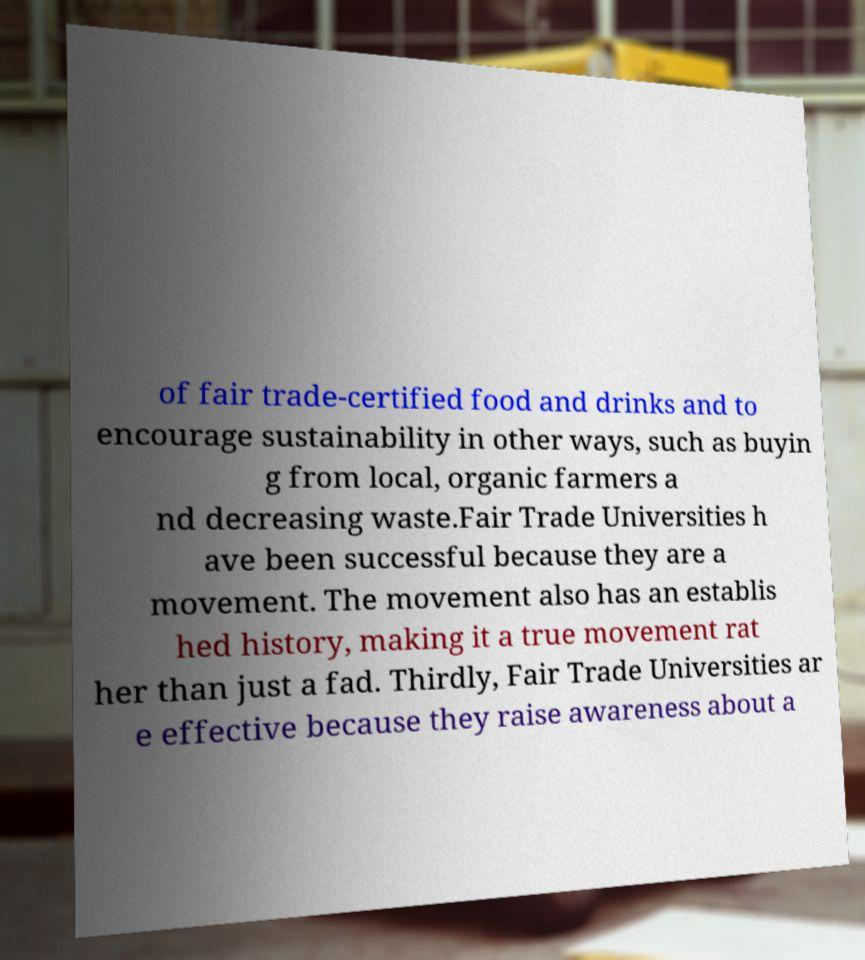Could you extract and type out the text from this image? of fair trade-certified food and drinks and to encourage sustainability in other ways, such as buyin g from local, organic farmers a nd decreasing waste.Fair Trade Universities h ave been successful because they are a movement. The movement also has an establis hed history, making it a true movement rat her than just a fad. Thirdly, Fair Trade Universities ar e effective because they raise awareness about a 